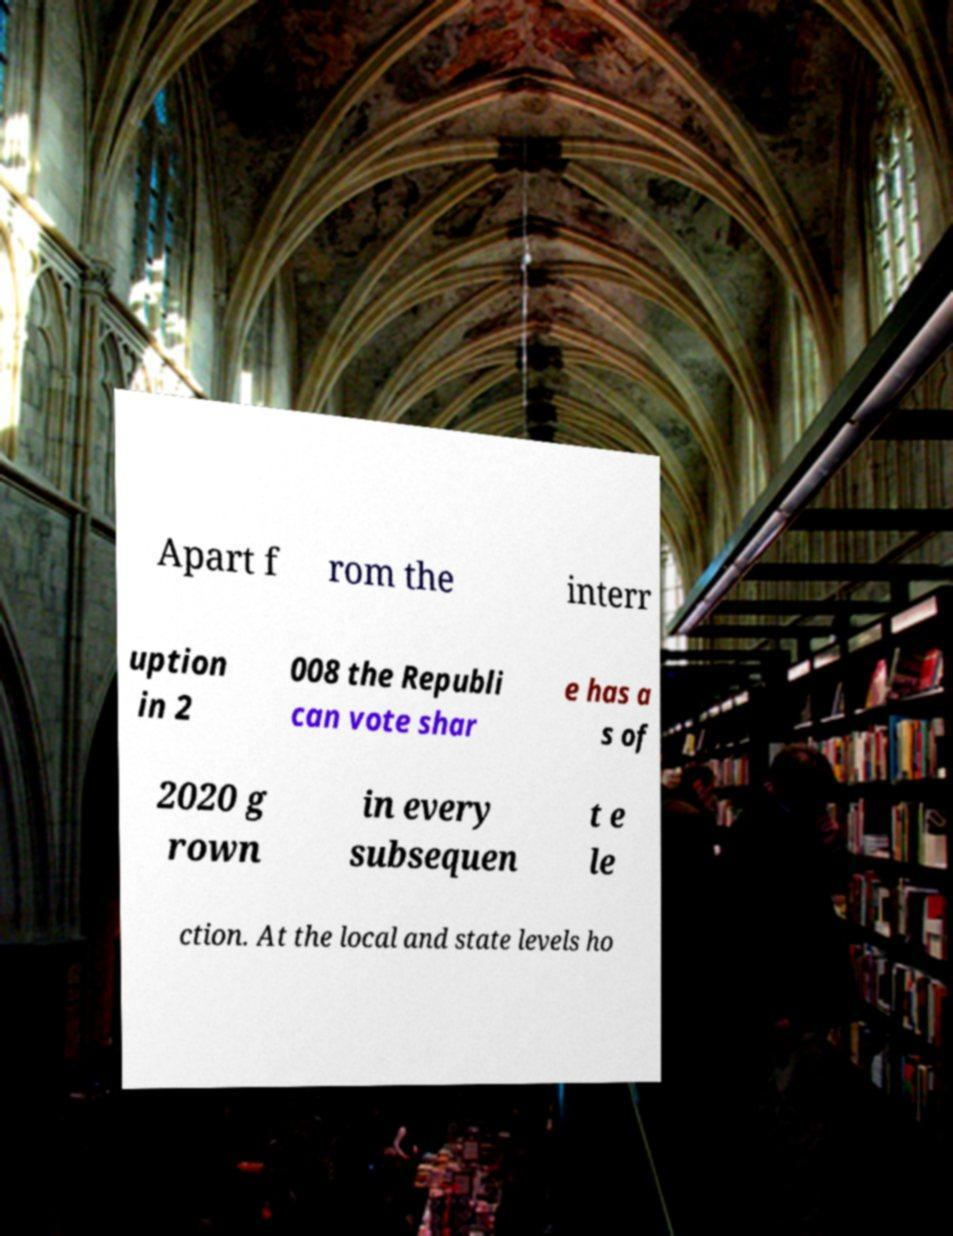Could you assist in decoding the text presented in this image and type it out clearly? Apart f rom the interr uption in 2 008 the Republi can vote shar e has a s of 2020 g rown in every subsequen t e le ction. At the local and state levels ho 